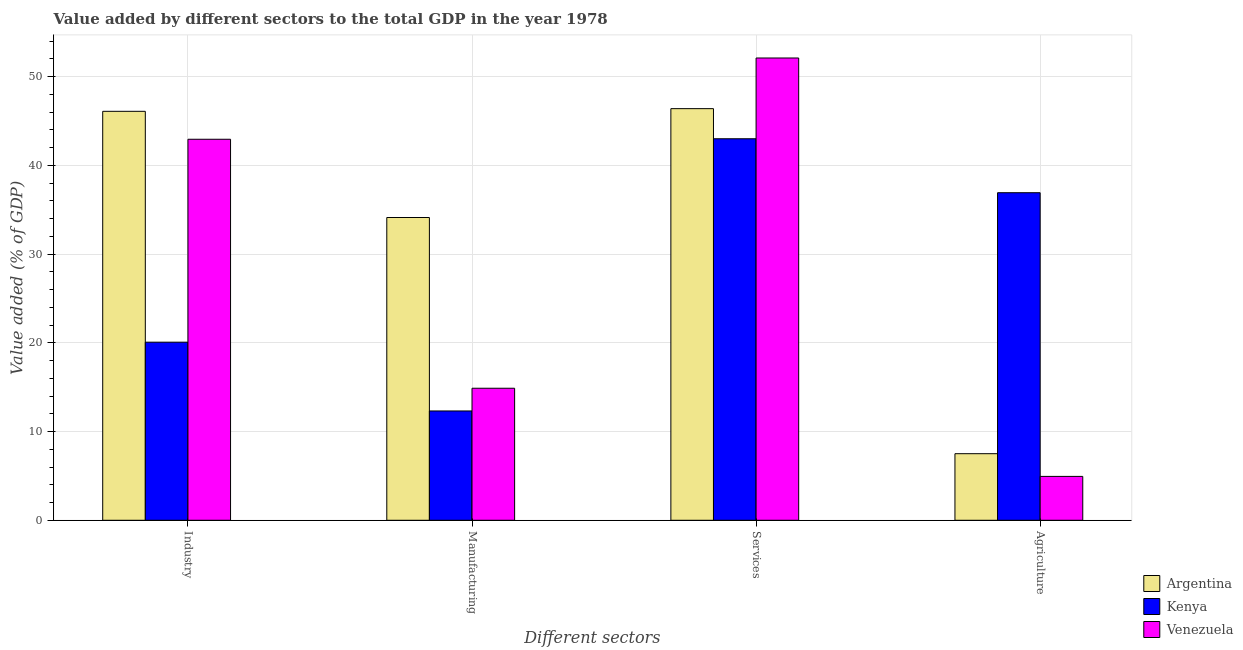Are the number of bars per tick equal to the number of legend labels?
Offer a terse response. Yes. How many bars are there on the 2nd tick from the left?
Provide a short and direct response. 3. What is the label of the 4th group of bars from the left?
Give a very brief answer. Agriculture. What is the value added by services sector in Venezuela?
Your answer should be compact. 52.11. Across all countries, what is the maximum value added by industrial sector?
Your answer should be very brief. 46.1. Across all countries, what is the minimum value added by agricultural sector?
Offer a very short reply. 4.94. In which country was the value added by industrial sector maximum?
Make the answer very short. Argentina. In which country was the value added by industrial sector minimum?
Ensure brevity in your answer.  Kenya. What is the total value added by industrial sector in the graph?
Ensure brevity in your answer.  109.12. What is the difference between the value added by agricultural sector in Venezuela and that in Kenya?
Keep it short and to the point. -31.98. What is the difference between the value added by services sector in Argentina and the value added by industrial sector in Venezuela?
Your answer should be very brief. 3.45. What is the average value added by services sector per country?
Give a very brief answer. 47.17. What is the difference between the value added by manufacturing sector and value added by services sector in Venezuela?
Provide a succinct answer. -37.23. In how many countries, is the value added by industrial sector greater than 32 %?
Your answer should be compact. 2. What is the ratio of the value added by services sector in Argentina to that in Venezuela?
Offer a very short reply. 0.89. Is the value added by industrial sector in Kenya less than that in Venezuela?
Offer a very short reply. Yes. What is the difference between the highest and the second highest value added by services sector?
Your response must be concise. 5.71. What is the difference between the highest and the lowest value added by industrial sector?
Provide a succinct answer. 26.02. In how many countries, is the value added by industrial sector greater than the average value added by industrial sector taken over all countries?
Make the answer very short. 2. Is the sum of the value added by industrial sector in Argentina and Kenya greater than the maximum value added by services sector across all countries?
Provide a succinct answer. Yes. What does the 3rd bar from the left in Manufacturing represents?
Offer a very short reply. Venezuela. What does the 2nd bar from the right in Manufacturing represents?
Provide a short and direct response. Kenya. How many bars are there?
Offer a terse response. 12. How many countries are there in the graph?
Your answer should be compact. 3. How are the legend labels stacked?
Your answer should be very brief. Vertical. What is the title of the graph?
Your answer should be very brief. Value added by different sectors to the total GDP in the year 1978. Does "Colombia" appear as one of the legend labels in the graph?
Your response must be concise. No. What is the label or title of the X-axis?
Offer a terse response. Different sectors. What is the label or title of the Y-axis?
Offer a very short reply. Value added (% of GDP). What is the Value added (% of GDP) in Argentina in Industry?
Your response must be concise. 46.1. What is the Value added (% of GDP) in Kenya in Industry?
Offer a very short reply. 20.07. What is the Value added (% of GDP) of Venezuela in Industry?
Your answer should be very brief. 42.95. What is the Value added (% of GDP) in Argentina in Manufacturing?
Your answer should be compact. 34.13. What is the Value added (% of GDP) of Kenya in Manufacturing?
Give a very brief answer. 12.32. What is the Value added (% of GDP) in Venezuela in Manufacturing?
Give a very brief answer. 14.88. What is the Value added (% of GDP) in Argentina in Services?
Offer a very short reply. 46.4. What is the Value added (% of GDP) of Kenya in Services?
Ensure brevity in your answer.  43. What is the Value added (% of GDP) of Venezuela in Services?
Offer a very short reply. 52.11. What is the Value added (% of GDP) of Argentina in Agriculture?
Offer a very short reply. 7.5. What is the Value added (% of GDP) of Kenya in Agriculture?
Ensure brevity in your answer.  36.92. What is the Value added (% of GDP) in Venezuela in Agriculture?
Offer a terse response. 4.94. Across all Different sectors, what is the maximum Value added (% of GDP) in Argentina?
Keep it short and to the point. 46.4. Across all Different sectors, what is the maximum Value added (% of GDP) in Kenya?
Offer a very short reply. 43. Across all Different sectors, what is the maximum Value added (% of GDP) in Venezuela?
Give a very brief answer. 52.11. Across all Different sectors, what is the minimum Value added (% of GDP) of Argentina?
Keep it short and to the point. 7.5. Across all Different sectors, what is the minimum Value added (% of GDP) in Kenya?
Your answer should be very brief. 12.32. Across all Different sectors, what is the minimum Value added (% of GDP) in Venezuela?
Offer a terse response. 4.94. What is the total Value added (% of GDP) in Argentina in the graph?
Ensure brevity in your answer.  134.13. What is the total Value added (% of GDP) of Kenya in the graph?
Offer a very short reply. 112.32. What is the total Value added (% of GDP) in Venezuela in the graph?
Ensure brevity in your answer.  114.88. What is the difference between the Value added (% of GDP) of Argentina in Industry and that in Manufacturing?
Keep it short and to the point. 11.97. What is the difference between the Value added (% of GDP) in Kenya in Industry and that in Manufacturing?
Offer a terse response. 7.75. What is the difference between the Value added (% of GDP) in Venezuela in Industry and that in Manufacturing?
Offer a terse response. 28.07. What is the difference between the Value added (% of GDP) of Argentina in Industry and that in Services?
Give a very brief answer. -0.3. What is the difference between the Value added (% of GDP) in Kenya in Industry and that in Services?
Offer a very short reply. -22.93. What is the difference between the Value added (% of GDP) of Venezuela in Industry and that in Services?
Your response must be concise. -9.16. What is the difference between the Value added (% of GDP) of Argentina in Industry and that in Agriculture?
Give a very brief answer. 38.59. What is the difference between the Value added (% of GDP) of Kenya in Industry and that in Agriculture?
Your answer should be very brief. -16.85. What is the difference between the Value added (% of GDP) of Venezuela in Industry and that in Agriculture?
Keep it short and to the point. 38. What is the difference between the Value added (% of GDP) in Argentina in Manufacturing and that in Services?
Your answer should be very brief. -12.27. What is the difference between the Value added (% of GDP) of Kenya in Manufacturing and that in Services?
Make the answer very short. -30.68. What is the difference between the Value added (% of GDP) in Venezuela in Manufacturing and that in Services?
Make the answer very short. -37.23. What is the difference between the Value added (% of GDP) in Argentina in Manufacturing and that in Agriculture?
Offer a very short reply. 26.62. What is the difference between the Value added (% of GDP) of Kenya in Manufacturing and that in Agriculture?
Provide a succinct answer. -24.6. What is the difference between the Value added (% of GDP) in Venezuela in Manufacturing and that in Agriculture?
Make the answer very short. 9.94. What is the difference between the Value added (% of GDP) in Argentina in Services and that in Agriculture?
Provide a short and direct response. 38.89. What is the difference between the Value added (% of GDP) in Kenya in Services and that in Agriculture?
Make the answer very short. 6.08. What is the difference between the Value added (% of GDP) of Venezuela in Services and that in Agriculture?
Make the answer very short. 47.16. What is the difference between the Value added (% of GDP) in Argentina in Industry and the Value added (% of GDP) in Kenya in Manufacturing?
Offer a terse response. 33.78. What is the difference between the Value added (% of GDP) of Argentina in Industry and the Value added (% of GDP) of Venezuela in Manufacturing?
Keep it short and to the point. 31.22. What is the difference between the Value added (% of GDP) in Kenya in Industry and the Value added (% of GDP) in Venezuela in Manufacturing?
Offer a very short reply. 5.19. What is the difference between the Value added (% of GDP) of Argentina in Industry and the Value added (% of GDP) of Kenya in Services?
Make the answer very short. 3.09. What is the difference between the Value added (% of GDP) of Argentina in Industry and the Value added (% of GDP) of Venezuela in Services?
Provide a succinct answer. -6.01. What is the difference between the Value added (% of GDP) of Kenya in Industry and the Value added (% of GDP) of Venezuela in Services?
Your response must be concise. -32.03. What is the difference between the Value added (% of GDP) of Argentina in Industry and the Value added (% of GDP) of Kenya in Agriculture?
Make the answer very short. 9.18. What is the difference between the Value added (% of GDP) in Argentina in Industry and the Value added (% of GDP) in Venezuela in Agriculture?
Your response must be concise. 41.15. What is the difference between the Value added (% of GDP) of Kenya in Industry and the Value added (% of GDP) of Venezuela in Agriculture?
Give a very brief answer. 15.13. What is the difference between the Value added (% of GDP) in Argentina in Manufacturing and the Value added (% of GDP) in Kenya in Services?
Your answer should be very brief. -8.88. What is the difference between the Value added (% of GDP) in Argentina in Manufacturing and the Value added (% of GDP) in Venezuela in Services?
Provide a short and direct response. -17.98. What is the difference between the Value added (% of GDP) of Kenya in Manufacturing and the Value added (% of GDP) of Venezuela in Services?
Provide a short and direct response. -39.79. What is the difference between the Value added (% of GDP) of Argentina in Manufacturing and the Value added (% of GDP) of Kenya in Agriculture?
Your answer should be compact. -2.79. What is the difference between the Value added (% of GDP) in Argentina in Manufacturing and the Value added (% of GDP) in Venezuela in Agriculture?
Offer a very short reply. 29.18. What is the difference between the Value added (% of GDP) of Kenya in Manufacturing and the Value added (% of GDP) of Venezuela in Agriculture?
Make the answer very short. 7.38. What is the difference between the Value added (% of GDP) of Argentina in Services and the Value added (% of GDP) of Kenya in Agriculture?
Give a very brief answer. 9.48. What is the difference between the Value added (% of GDP) in Argentina in Services and the Value added (% of GDP) in Venezuela in Agriculture?
Provide a short and direct response. 41.45. What is the difference between the Value added (% of GDP) in Kenya in Services and the Value added (% of GDP) in Venezuela in Agriculture?
Provide a succinct answer. 38.06. What is the average Value added (% of GDP) in Argentina per Different sectors?
Keep it short and to the point. 33.53. What is the average Value added (% of GDP) of Kenya per Different sectors?
Give a very brief answer. 28.08. What is the average Value added (% of GDP) in Venezuela per Different sectors?
Your response must be concise. 28.72. What is the difference between the Value added (% of GDP) of Argentina and Value added (% of GDP) of Kenya in Industry?
Provide a short and direct response. 26.02. What is the difference between the Value added (% of GDP) in Argentina and Value added (% of GDP) in Venezuela in Industry?
Offer a very short reply. 3.15. What is the difference between the Value added (% of GDP) in Kenya and Value added (% of GDP) in Venezuela in Industry?
Offer a terse response. -22.87. What is the difference between the Value added (% of GDP) of Argentina and Value added (% of GDP) of Kenya in Manufacturing?
Your answer should be very brief. 21.81. What is the difference between the Value added (% of GDP) in Argentina and Value added (% of GDP) in Venezuela in Manufacturing?
Keep it short and to the point. 19.25. What is the difference between the Value added (% of GDP) in Kenya and Value added (% of GDP) in Venezuela in Manufacturing?
Ensure brevity in your answer.  -2.56. What is the difference between the Value added (% of GDP) of Argentina and Value added (% of GDP) of Kenya in Services?
Make the answer very short. 3.39. What is the difference between the Value added (% of GDP) in Argentina and Value added (% of GDP) in Venezuela in Services?
Provide a short and direct response. -5.71. What is the difference between the Value added (% of GDP) in Kenya and Value added (% of GDP) in Venezuela in Services?
Give a very brief answer. -9.1. What is the difference between the Value added (% of GDP) of Argentina and Value added (% of GDP) of Kenya in Agriculture?
Ensure brevity in your answer.  -29.42. What is the difference between the Value added (% of GDP) of Argentina and Value added (% of GDP) of Venezuela in Agriculture?
Provide a short and direct response. 2.56. What is the difference between the Value added (% of GDP) of Kenya and Value added (% of GDP) of Venezuela in Agriculture?
Your response must be concise. 31.98. What is the ratio of the Value added (% of GDP) of Argentina in Industry to that in Manufacturing?
Give a very brief answer. 1.35. What is the ratio of the Value added (% of GDP) in Kenya in Industry to that in Manufacturing?
Provide a short and direct response. 1.63. What is the ratio of the Value added (% of GDP) in Venezuela in Industry to that in Manufacturing?
Provide a short and direct response. 2.89. What is the ratio of the Value added (% of GDP) of Argentina in Industry to that in Services?
Keep it short and to the point. 0.99. What is the ratio of the Value added (% of GDP) in Kenya in Industry to that in Services?
Provide a succinct answer. 0.47. What is the ratio of the Value added (% of GDP) in Venezuela in Industry to that in Services?
Make the answer very short. 0.82. What is the ratio of the Value added (% of GDP) of Argentina in Industry to that in Agriculture?
Your response must be concise. 6.14. What is the ratio of the Value added (% of GDP) in Kenya in Industry to that in Agriculture?
Give a very brief answer. 0.54. What is the ratio of the Value added (% of GDP) in Venezuela in Industry to that in Agriculture?
Ensure brevity in your answer.  8.69. What is the ratio of the Value added (% of GDP) of Argentina in Manufacturing to that in Services?
Keep it short and to the point. 0.74. What is the ratio of the Value added (% of GDP) of Kenya in Manufacturing to that in Services?
Give a very brief answer. 0.29. What is the ratio of the Value added (% of GDP) of Venezuela in Manufacturing to that in Services?
Offer a terse response. 0.29. What is the ratio of the Value added (% of GDP) in Argentina in Manufacturing to that in Agriculture?
Ensure brevity in your answer.  4.55. What is the ratio of the Value added (% of GDP) in Kenya in Manufacturing to that in Agriculture?
Provide a succinct answer. 0.33. What is the ratio of the Value added (% of GDP) in Venezuela in Manufacturing to that in Agriculture?
Your response must be concise. 3.01. What is the ratio of the Value added (% of GDP) in Argentina in Services to that in Agriculture?
Ensure brevity in your answer.  6.18. What is the ratio of the Value added (% of GDP) in Kenya in Services to that in Agriculture?
Your response must be concise. 1.16. What is the ratio of the Value added (% of GDP) of Venezuela in Services to that in Agriculture?
Your response must be concise. 10.54. What is the difference between the highest and the second highest Value added (% of GDP) of Argentina?
Offer a terse response. 0.3. What is the difference between the highest and the second highest Value added (% of GDP) of Kenya?
Your answer should be compact. 6.08. What is the difference between the highest and the second highest Value added (% of GDP) of Venezuela?
Your answer should be compact. 9.16. What is the difference between the highest and the lowest Value added (% of GDP) of Argentina?
Ensure brevity in your answer.  38.89. What is the difference between the highest and the lowest Value added (% of GDP) of Kenya?
Ensure brevity in your answer.  30.68. What is the difference between the highest and the lowest Value added (% of GDP) of Venezuela?
Provide a succinct answer. 47.16. 